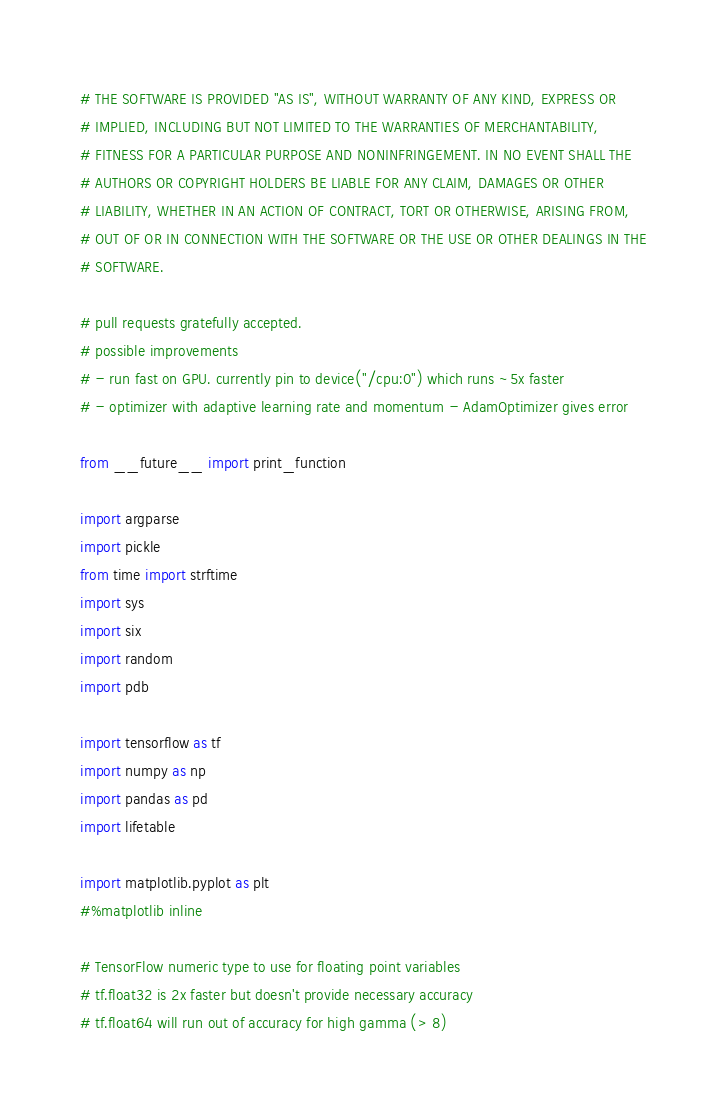Convert code to text. <code><loc_0><loc_0><loc_500><loc_500><_Python_>
# THE SOFTWARE IS PROVIDED "AS IS", WITHOUT WARRANTY OF ANY KIND, EXPRESS OR
# IMPLIED, INCLUDING BUT NOT LIMITED TO THE WARRANTIES OF MERCHANTABILITY,
# FITNESS FOR A PARTICULAR PURPOSE AND NONINFRINGEMENT. IN NO EVENT SHALL THE
# AUTHORS OR COPYRIGHT HOLDERS BE LIABLE FOR ANY CLAIM, DAMAGES OR OTHER
# LIABILITY, WHETHER IN AN ACTION OF CONTRACT, TORT OR OTHERWISE, ARISING FROM,
# OUT OF OR IN CONNECTION WITH THE SOFTWARE OR THE USE OR OTHER DEALINGS IN THE
# SOFTWARE.

# pull requests gratefully accepted.
# possible improvements
# - run fast on GPU. currently pin to device("/cpu:0") which runs ~5x faster 
# - optimizer with adaptive learning rate and momentum - AdamOptimizer gives error

from __future__ import print_function

import argparse
import pickle
from time import strftime
import sys
import six
import random
import pdb

import tensorflow as tf
import numpy as np
import pandas as pd
import lifetable

import matplotlib.pyplot as plt
#%matplotlib inline

# TensorFlow numeric type to use for floating point variables
# tf.float32 is 2x faster but doesn't provide necessary accuracy
# tf.float64 will run out of accuracy for high gamma (> 8)</code> 